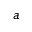Convert formula to latex. <formula><loc_0><loc_0><loc_500><loc_500>^ { a }</formula> 